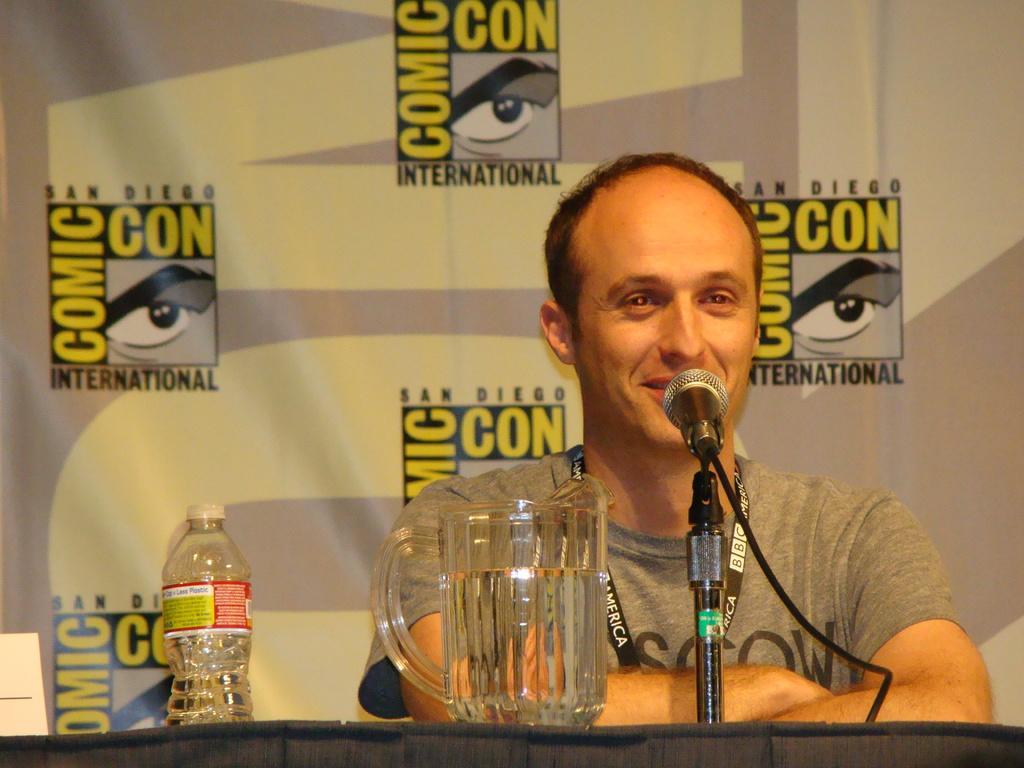Please provide a concise description of this image. In the middle of the image a man is speaking on microphone. In front of him there is table, On the table there is a glass. Behind the glass there is a water bottle. Behind the man there is a banner. 